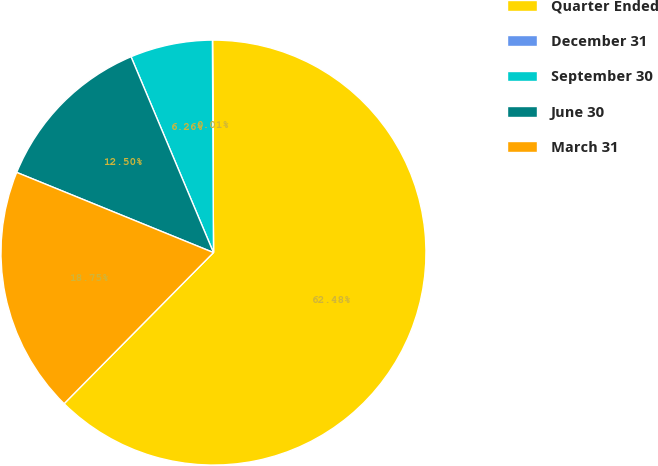Convert chart to OTSL. <chart><loc_0><loc_0><loc_500><loc_500><pie_chart><fcel>Quarter Ended<fcel>December 31<fcel>September 30<fcel>June 30<fcel>March 31<nl><fcel>62.48%<fcel>0.01%<fcel>6.26%<fcel>12.5%<fcel>18.75%<nl></chart> 